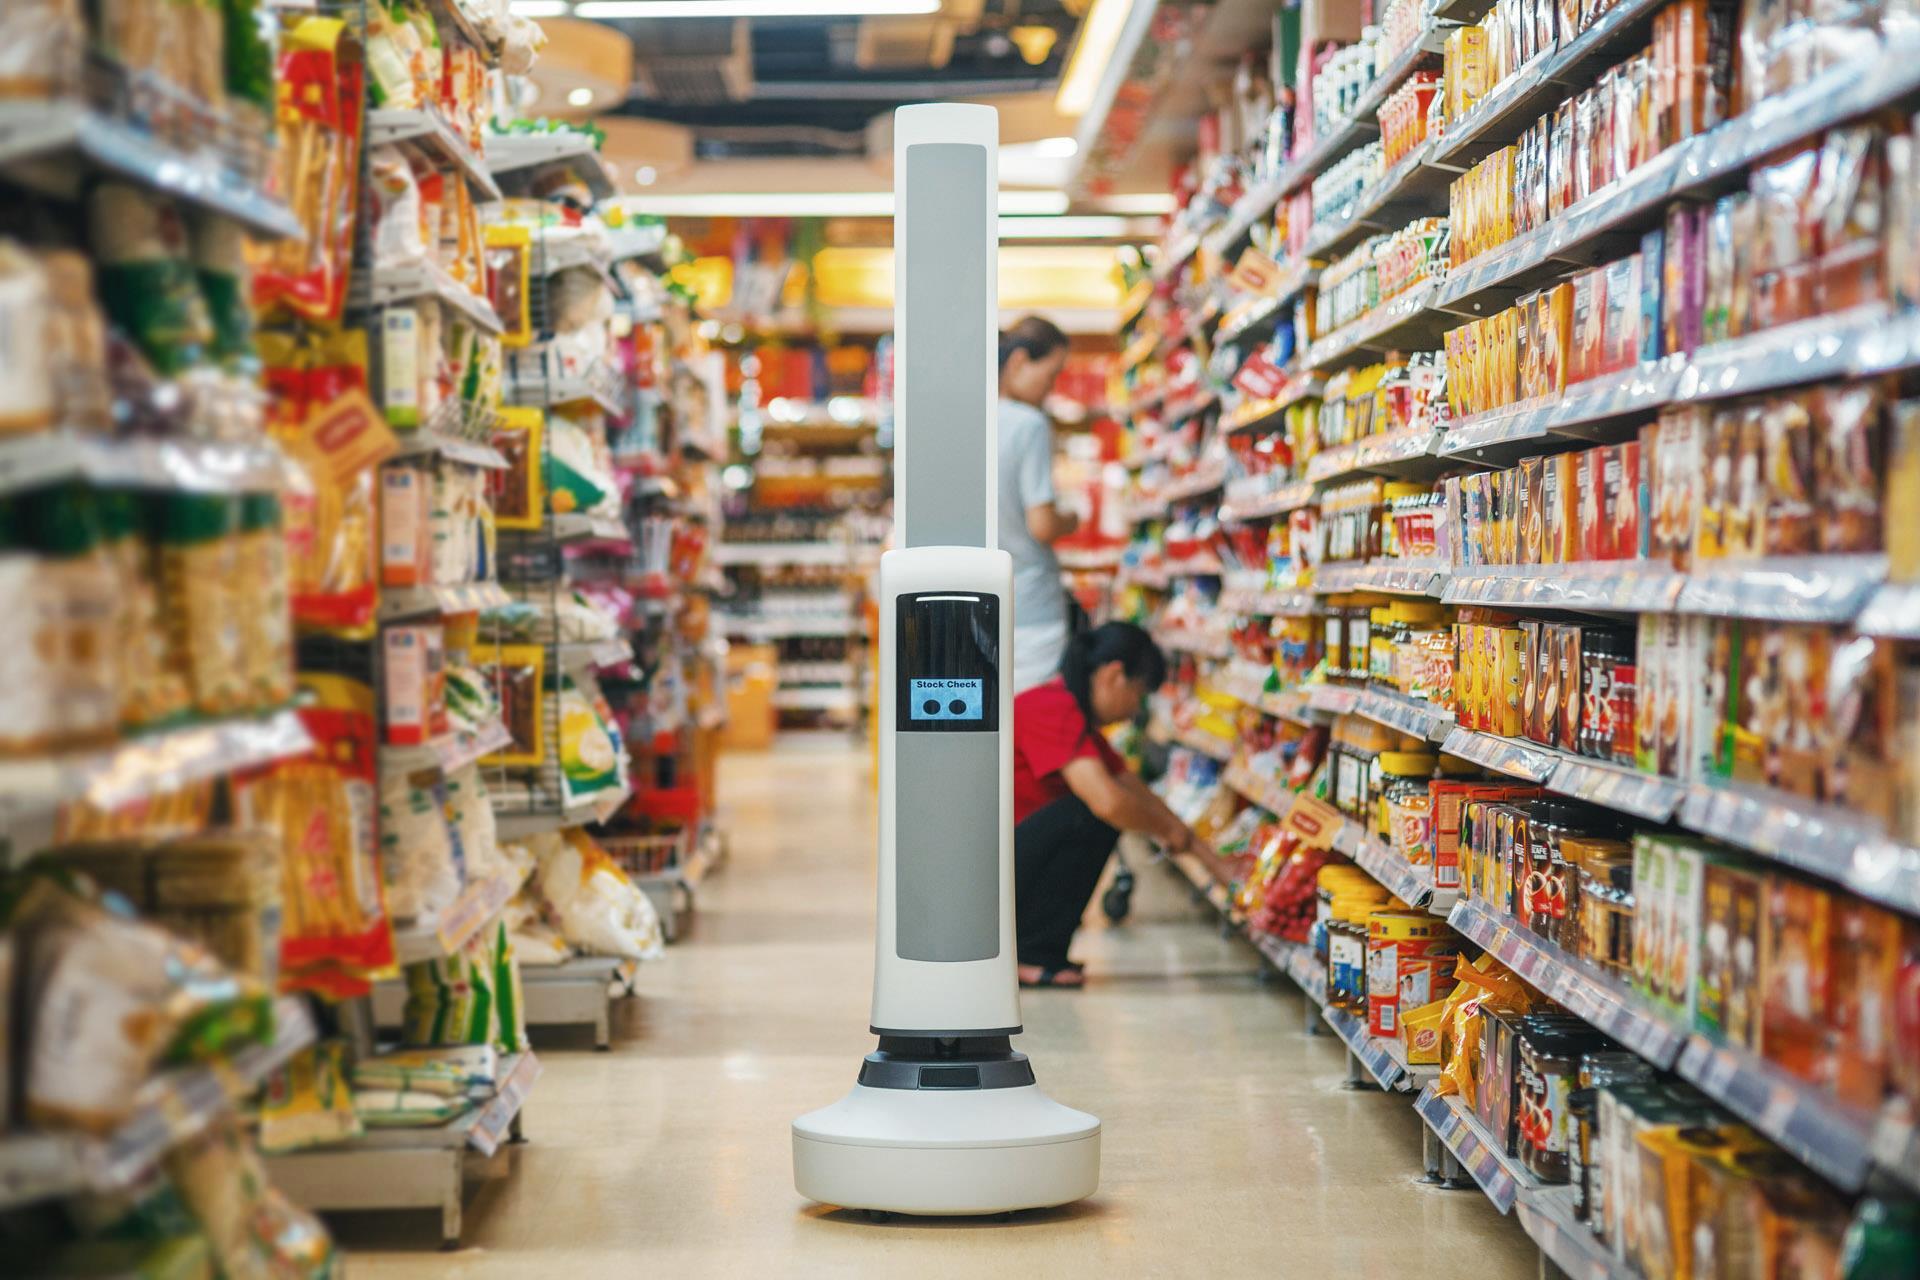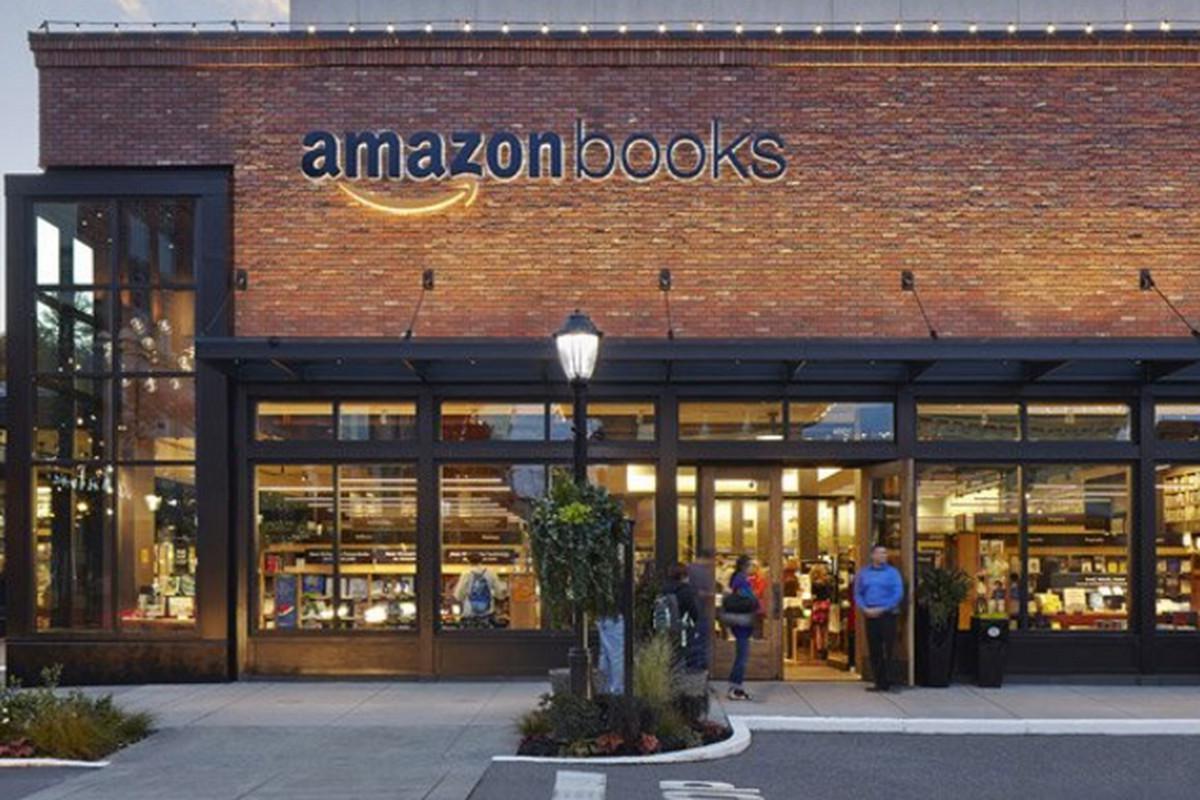The first image is the image on the left, the second image is the image on the right. Given the left and right images, does the statement "One image shows the front entrance of an Amazon books store." hold true? Answer yes or no. Yes. The first image is the image on the left, the second image is the image on the right. Examine the images to the left and right. Is the description "the left image has 2 cash registers" accurate? Answer yes or no. No. 